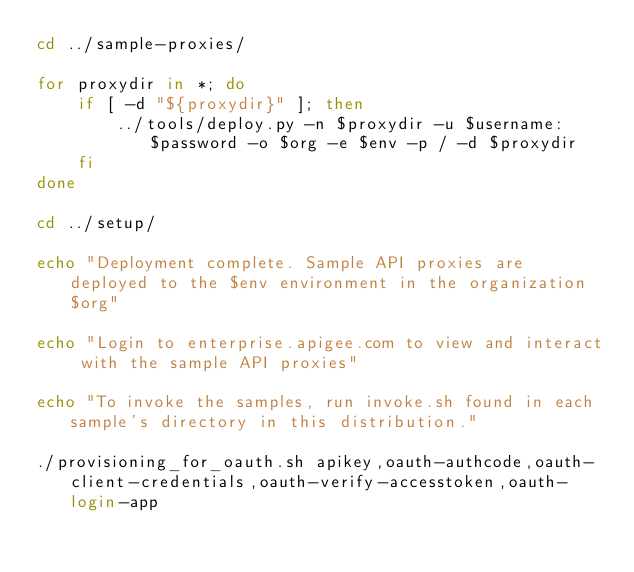<code> <loc_0><loc_0><loc_500><loc_500><_Bash_>cd ../sample-proxies/

for proxydir in *; do
    if [ -d "${proxydir}" ]; then
        ../tools/deploy.py -n $proxydir -u $username:$password -o $org -e $env -p / -d $proxydir
    fi
done

cd ../setup/

echo "Deployment complete. Sample API proxies are deployed to the $env environment in the organization $org"

echo "Login to enterprise.apigee.com to view and interact with the sample API proxies"

echo "To invoke the samples, run invoke.sh found in each sample's directory in this distribution."

./provisioning_for_oauth.sh apikey,oauth-authcode,oauth-client-credentials,oauth-verify-accesstoken,oauth-login-app
</code> 